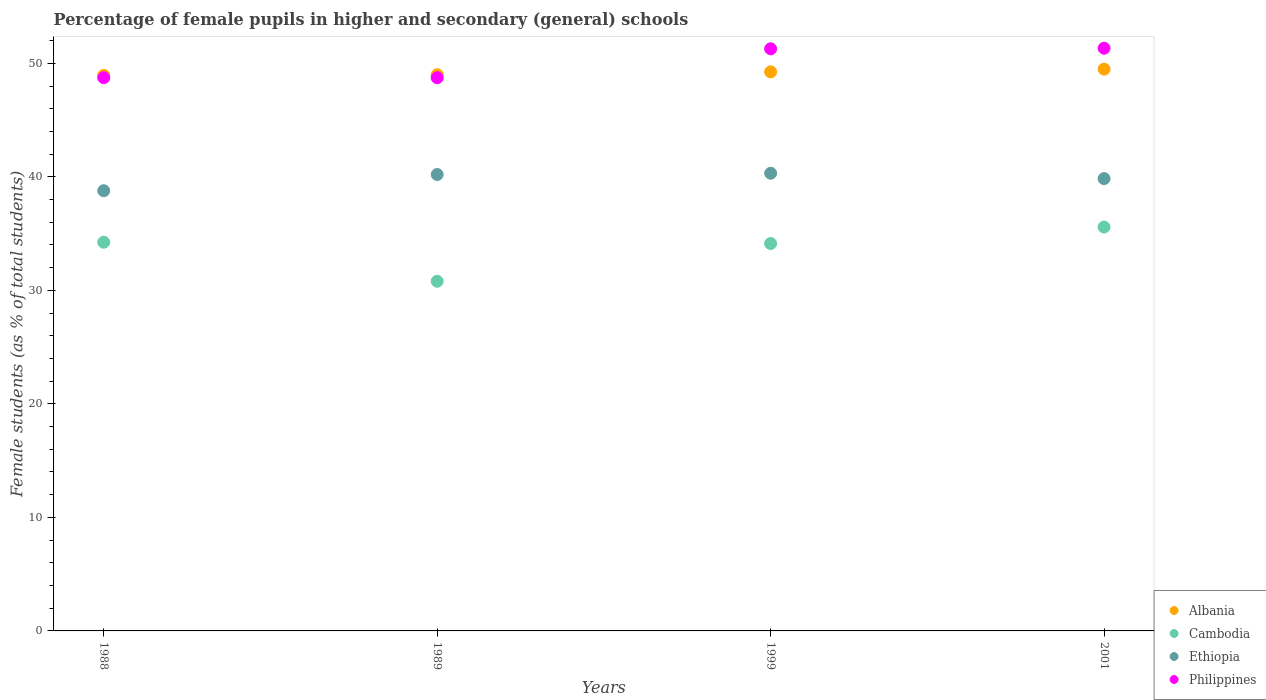What is the percentage of female pupils in higher and secondary schools in Albania in 1989?
Make the answer very short. 48.99. Across all years, what is the maximum percentage of female pupils in higher and secondary schools in Cambodia?
Make the answer very short. 35.57. Across all years, what is the minimum percentage of female pupils in higher and secondary schools in Ethiopia?
Provide a succinct answer. 38.78. What is the total percentage of female pupils in higher and secondary schools in Ethiopia in the graph?
Provide a short and direct response. 159.14. What is the difference between the percentage of female pupils in higher and secondary schools in Cambodia in 1989 and that in 2001?
Your response must be concise. -4.77. What is the difference between the percentage of female pupils in higher and secondary schools in Ethiopia in 1988 and the percentage of female pupils in higher and secondary schools in Cambodia in 1999?
Your response must be concise. 4.65. What is the average percentage of female pupils in higher and secondary schools in Albania per year?
Ensure brevity in your answer.  49.16. In the year 1988, what is the difference between the percentage of female pupils in higher and secondary schools in Ethiopia and percentage of female pupils in higher and secondary schools in Albania?
Give a very brief answer. -10.16. What is the ratio of the percentage of female pupils in higher and secondary schools in Philippines in 1988 to that in 2001?
Your answer should be compact. 0.95. Is the percentage of female pupils in higher and secondary schools in Ethiopia in 1999 less than that in 2001?
Offer a very short reply. No. Is the difference between the percentage of female pupils in higher and secondary schools in Ethiopia in 1988 and 2001 greater than the difference between the percentage of female pupils in higher and secondary schools in Albania in 1988 and 2001?
Provide a short and direct response. No. What is the difference between the highest and the second highest percentage of female pupils in higher and secondary schools in Cambodia?
Provide a short and direct response. 1.34. What is the difference between the highest and the lowest percentage of female pupils in higher and secondary schools in Ethiopia?
Offer a very short reply. 1.54. Is it the case that in every year, the sum of the percentage of female pupils in higher and secondary schools in Cambodia and percentage of female pupils in higher and secondary schools in Philippines  is greater than the sum of percentage of female pupils in higher and secondary schools in Albania and percentage of female pupils in higher and secondary schools in Ethiopia?
Provide a succinct answer. No. Is it the case that in every year, the sum of the percentage of female pupils in higher and secondary schools in Cambodia and percentage of female pupils in higher and secondary schools in Ethiopia  is greater than the percentage of female pupils in higher and secondary schools in Albania?
Offer a terse response. Yes. Is the percentage of female pupils in higher and secondary schools in Philippines strictly greater than the percentage of female pupils in higher and secondary schools in Ethiopia over the years?
Your response must be concise. Yes. How many dotlines are there?
Your response must be concise. 4. What is the difference between two consecutive major ticks on the Y-axis?
Offer a very short reply. 10. Does the graph contain any zero values?
Ensure brevity in your answer.  No. What is the title of the graph?
Provide a succinct answer. Percentage of female pupils in higher and secondary (general) schools. What is the label or title of the Y-axis?
Offer a terse response. Female students (as % of total students). What is the Female students (as % of total students) of Albania in 1988?
Ensure brevity in your answer.  48.94. What is the Female students (as % of total students) in Cambodia in 1988?
Provide a short and direct response. 34.24. What is the Female students (as % of total students) of Ethiopia in 1988?
Give a very brief answer. 38.78. What is the Female students (as % of total students) of Philippines in 1988?
Provide a succinct answer. 48.73. What is the Female students (as % of total students) of Albania in 1989?
Offer a terse response. 48.99. What is the Female students (as % of total students) in Cambodia in 1989?
Your answer should be compact. 30.8. What is the Female students (as % of total students) of Ethiopia in 1989?
Give a very brief answer. 40.2. What is the Female students (as % of total students) of Philippines in 1989?
Give a very brief answer. 48.73. What is the Female students (as % of total students) of Albania in 1999?
Your answer should be very brief. 49.25. What is the Female students (as % of total students) in Cambodia in 1999?
Offer a very short reply. 34.13. What is the Female students (as % of total students) in Ethiopia in 1999?
Make the answer very short. 40.31. What is the Female students (as % of total students) in Philippines in 1999?
Offer a very short reply. 51.28. What is the Female students (as % of total students) in Albania in 2001?
Offer a terse response. 49.48. What is the Female students (as % of total students) in Cambodia in 2001?
Give a very brief answer. 35.57. What is the Female students (as % of total students) of Ethiopia in 2001?
Offer a very short reply. 39.84. What is the Female students (as % of total students) in Philippines in 2001?
Provide a succinct answer. 51.33. Across all years, what is the maximum Female students (as % of total students) of Albania?
Offer a terse response. 49.48. Across all years, what is the maximum Female students (as % of total students) in Cambodia?
Make the answer very short. 35.57. Across all years, what is the maximum Female students (as % of total students) in Ethiopia?
Your answer should be compact. 40.31. Across all years, what is the maximum Female students (as % of total students) in Philippines?
Ensure brevity in your answer.  51.33. Across all years, what is the minimum Female students (as % of total students) in Albania?
Make the answer very short. 48.94. Across all years, what is the minimum Female students (as % of total students) of Cambodia?
Offer a very short reply. 30.8. Across all years, what is the minimum Female students (as % of total students) of Ethiopia?
Offer a very short reply. 38.78. Across all years, what is the minimum Female students (as % of total students) of Philippines?
Give a very brief answer. 48.73. What is the total Female students (as % of total students) in Albania in the graph?
Your response must be concise. 196.66. What is the total Female students (as % of total students) in Cambodia in the graph?
Ensure brevity in your answer.  134.75. What is the total Female students (as % of total students) in Ethiopia in the graph?
Provide a short and direct response. 159.14. What is the total Female students (as % of total students) of Philippines in the graph?
Provide a short and direct response. 200.07. What is the difference between the Female students (as % of total students) in Albania in 1988 and that in 1989?
Your answer should be compact. -0.06. What is the difference between the Female students (as % of total students) in Cambodia in 1988 and that in 1989?
Provide a short and direct response. 3.44. What is the difference between the Female students (as % of total students) in Ethiopia in 1988 and that in 1989?
Give a very brief answer. -1.43. What is the difference between the Female students (as % of total students) of Philippines in 1988 and that in 1989?
Give a very brief answer. 0. What is the difference between the Female students (as % of total students) in Albania in 1988 and that in 1999?
Provide a succinct answer. -0.31. What is the difference between the Female students (as % of total students) in Cambodia in 1988 and that in 1999?
Give a very brief answer. 0.11. What is the difference between the Female students (as % of total students) of Ethiopia in 1988 and that in 1999?
Your response must be concise. -1.54. What is the difference between the Female students (as % of total students) in Philippines in 1988 and that in 1999?
Provide a short and direct response. -2.55. What is the difference between the Female students (as % of total students) in Albania in 1988 and that in 2001?
Your response must be concise. -0.55. What is the difference between the Female students (as % of total students) in Cambodia in 1988 and that in 2001?
Your answer should be compact. -1.34. What is the difference between the Female students (as % of total students) in Ethiopia in 1988 and that in 2001?
Your answer should be very brief. -1.07. What is the difference between the Female students (as % of total students) in Philippines in 1988 and that in 2001?
Your answer should be compact. -2.6. What is the difference between the Female students (as % of total students) of Albania in 1989 and that in 1999?
Your answer should be very brief. -0.25. What is the difference between the Female students (as % of total students) in Cambodia in 1989 and that in 1999?
Your response must be concise. -3.32. What is the difference between the Female students (as % of total students) in Ethiopia in 1989 and that in 1999?
Provide a short and direct response. -0.11. What is the difference between the Female students (as % of total students) in Philippines in 1989 and that in 1999?
Make the answer very short. -2.55. What is the difference between the Female students (as % of total students) of Albania in 1989 and that in 2001?
Your answer should be very brief. -0.49. What is the difference between the Female students (as % of total students) of Cambodia in 1989 and that in 2001?
Make the answer very short. -4.77. What is the difference between the Female students (as % of total students) of Ethiopia in 1989 and that in 2001?
Keep it short and to the point. 0.36. What is the difference between the Female students (as % of total students) of Philippines in 1989 and that in 2001?
Offer a terse response. -2.6. What is the difference between the Female students (as % of total students) of Albania in 1999 and that in 2001?
Provide a succinct answer. -0.24. What is the difference between the Female students (as % of total students) in Cambodia in 1999 and that in 2001?
Provide a succinct answer. -1.45. What is the difference between the Female students (as % of total students) of Ethiopia in 1999 and that in 2001?
Your answer should be compact. 0.47. What is the difference between the Female students (as % of total students) of Philippines in 1999 and that in 2001?
Keep it short and to the point. -0.05. What is the difference between the Female students (as % of total students) in Albania in 1988 and the Female students (as % of total students) in Cambodia in 1989?
Keep it short and to the point. 18.13. What is the difference between the Female students (as % of total students) of Albania in 1988 and the Female students (as % of total students) of Ethiopia in 1989?
Offer a very short reply. 8.73. What is the difference between the Female students (as % of total students) in Albania in 1988 and the Female students (as % of total students) in Philippines in 1989?
Your response must be concise. 0.21. What is the difference between the Female students (as % of total students) in Cambodia in 1988 and the Female students (as % of total students) in Ethiopia in 1989?
Offer a very short reply. -5.96. What is the difference between the Female students (as % of total students) in Cambodia in 1988 and the Female students (as % of total students) in Philippines in 1989?
Your answer should be very brief. -14.49. What is the difference between the Female students (as % of total students) of Ethiopia in 1988 and the Female students (as % of total students) of Philippines in 1989?
Offer a terse response. -9.95. What is the difference between the Female students (as % of total students) in Albania in 1988 and the Female students (as % of total students) in Cambodia in 1999?
Provide a succinct answer. 14.81. What is the difference between the Female students (as % of total students) of Albania in 1988 and the Female students (as % of total students) of Ethiopia in 1999?
Make the answer very short. 8.62. What is the difference between the Female students (as % of total students) in Albania in 1988 and the Female students (as % of total students) in Philippines in 1999?
Your response must be concise. -2.34. What is the difference between the Female students (as % of total students) in Cambodia in 1988 and the Female students (as % of total students) in Ethiopia in 1999?
Provide a succinct answer. -6.08. What is the difference between the Female students (as % of total students) of Cambodia in 1988 and the Female students (as % of total students) of Philippines in 1999?
Your answer should be very brief. -17.04. What is the difference between the Female students (as % of total students) in Ethiopia in 1988 and the Female students (as % of total students) in Philippines in 1999?
Your answer should be very brief. -12.5. What is the difference between the Female students (as % of total students) in Albania in 1988 and the Female students (as % of total students) in Cambodia in 2001?
Make the answer very short. 13.36. What is the difference between the Female students (as % of total students) in Albania in 1988 and the Female students (as % of total students) in Ethiopia in 2001?
Your answer should be very brief. 9.09. What is the difference between the Female students (as % of total students) in Albania in 1988 and the Female students (as % of total students) in Philippines in 2001?
Give a very brief answer. -2.39. What is the difference between the Female students (as % of total students) in Cambodia in 1988 and the Female students (as % of total students) in Ethiopia in 2001?
Your response must be concise. -5.6. What is the difference between the Female students (as % of total students) of Cambodia in 1988 and the Female students (as % of total students) of Philippines in 2001?
Your answer should be compact. -17.09. What is the difference between the Female students (as % of total students) in Ethiopia in 1988 and the Female students (as % of total students) in Philippines in 2001?
Provide a succinct answer. -12.55. What is the difference between the Female students (as % of total students) of Albania in 1989 and the Female students (as % of total students) of Cambodia in 1999?
Make the answer very short. 14.87. What is the difference between the Female students (as % of total students) in Albania in 1989 and the Female students (as % of total students) in Ethiopia in 1999?
Ensure brevity in your answer.  8.68. What is the difference between the Female students (as % of total students) of Albania in 1989 and the Female students (as % of total students) of Philippines in 1999?
Your answer should be very brief. -2.28. What is the difference between the Female students (as % of total students) of Cambodia in 1989 and the Female students (as % of total students) of Ethiopia in 1999?
Give a very brief answer. -9.51. What is the difference between the Female students (as % of total students) of Cambodia in 1989 and the Female students (as % of total students) of Philippines in 1999?
Provide a short and direct response. -20.47. What is the difference between the Female students (as % of total students) in Ethiopia in 1989 and the Female students (as % of total students) in Philippines in 1999?
Ensure brevity in your answer.  -11.07. What is the difference between the Female students (as % of total students) of Albania in 1989 and the Female students (as % of total students) of Cambodia in 2001?
Provide a short and direct response. 13.42. What is the difference between the Female students (as % of total students) of Albania in 1989 and the Female students (as % of total students) of Ethiopia in 2001?
Ensure brevity in your answer.  9.15. What is the difference between the Female students (as % of total students) of Albania in 1989 and the Female students (as % of total students) of Philippines in 2001?
Make the answer very short. -2.33. What is the difference between the Female students (as % of total students) in Cambodia in 1989 and the Female students (as % of total students) in Ethiopia in 2001?
Make the answer very short. -9.04. What is the difference between the Female students (as % of total students) in Cambodia in 1989 and the Female students (as % of total students) in Philippines in 2001?
Your answer should be very brief. -20.52. What is the difference between the Female students (as % of total students) in Ethiopia in 1989 and the Female students (as % of total students) in Philippines in 2001?
Offer a terse response. -11.12. What is the difference between the Female students (as % of total students) of Albania in 1999 and the Female students (as % of total students) of Cambodia in 2001?
Keep it short and to the point. 13.67. What is the difference between the Female students (as % of total students) in Albania in 1999 and the Female students (as % of total students) in Ethiopia in 2001?
Offer a terse response. 9.4. What is the difference between the Female students (as % of total students) of Albania in 1999 and the Female students (as % of total students) of Philippines in 2001?
Provide a short and direct response. -2.08. What is the difference between the Female students (as % of total students) of Cambodia in 1999 and the Female students (as % of total students) of Ethiopia in 2001?
Provide a succinct answer. -5.72. What is the difference between the Female students (as % of total students) of Cambodia in 1999 and the Female students (as % of total students) of Philippines in 2001?
Provide a succinct answer. -17.2. What is the difference between the Female students (as % of total students) in Ethiopia in 1999 and the Female students (as % of total students) in Philippines in 2001?
Ensure brevity in your answer.  -11.01. What is the average Female students (as % of total students) in Albania per year?
Offer a very short reply. 49.16. What is the average Female students (as % of total students) in Cambodia per year?
Make the answer very short. 33.69. What is the average Female students (as % of total students) in Ethiopia per year?
Your response must be concise. 39.78. What is the average Female students (as % of total students) in Philippines per year?
Give a very brief answer. 50.02. In the year 1988, what is the difference between the Female students (as % of total students) of Albania and Female students (as % of total students) of Cambodia?
Your response must be concise. 14.7. In the year 1988, what is the difference between the Female students (as % of total students) of Albania and Female students (as % of total students) of Ethiopia?
Provide a short and direct response. 10.16. In the year 1988, what is the difference between the Female students (as % of total students) in Albania and Female students (as % of total students) in Philippines?
Provide a succinct answer. 0.21. In the year 1988, what is the difference between the Female students (as % of total students) in Cambodia and Female students (as % of total students) in Ethiopia?
Make the answer very short. -4.54. In the year 1988, what is the difference between the Female students (as % of total students) in Cambodia and Female students (as % of total students) in Philippines?
Your answer should be very brief. -14.49. In the year 1988, what is the difference between the Female students (as % of total students) in Ethiopia and Female students (as % of total students) in Philippines?
Your answer should be very brief. -9.95. In the year 1989, what is the difference between the Female students (as % of total students) of Albania and Female students (as % of total students) of Cambodia?
Offer a terse response. 18.19. In the year 1989, what is the difference between the Female students (as % of total students) in Albania and Female students (as % of total students) in Ethiopia?
Ensure brevity in your answer.  8.79. In the year 1989, what is the difference between the Female students (as % of total students) in Albania and Female students (as % of total students) in Philippines?
Keep it short and to the point. 0.26. In the year 1989, what is the difference between the Female students (as % of total students) in Cambodia and Female students (as % of total students) in Ethiopia?
Make the answer very short. -9.4. In the year 1989, what is the difference between the Female students (as % of total students) of Cambodia and Female students (as % of total students) of Philippines?
Ensure brevity in your answer.  -17.93. In the year 1989, what is the difference between the Female students (as % of total students) of Ethiopia and Female students (as % of total students) of Philippines?
Give a very brief answer. -8.53. In the year 1999, what is the difference between the Female students (as % of total students) of Albania and Female students (as % of total students) of Cambodia?
Make the answer very short. 15.12. In the year 1999, what is the difference between the Female students (as % of total students) in Albania and Female students (as % of total students) in Ethiopia?
Your answer should be compact. 8.93. In the year 1999, what is the difference between the Female students (as % of total students) of Albania and Female students (as % of total students) of Philippines?
Offer a terse response. -2.03. In the year 1999, what is the difference between the Female students (as % of total students) in Cambodia and Female students (as % of total students) in Ethiopia?
Ensure brevity in your answer.  -6.19. In the year 1999, what is the difference between the Female students (as % of total students) of Cambodia and Female students (as % of total students) of Philippines?
Provide a short and direct response. -17.15. In the year 1999, what is the difference between the Female students (as % of total students) in Ethiopia and Female students (as % of total students) in Philippines?
Your answer should be compact. -10.96. In the year 2001, what is the difference between the Female students (as % of total students) in Albania and Female students (as % of total students) in Cambodia?
Provide a succinct answer. 13.91. In the year 2001, what is the difference between the Female students (as % of total students) of Albania and Female students (as % of total students) of Ethiopia?
Offer a terse response. 9.64. In the year 2001, what is the difference between the Female students (as % of total students) in Albania and Female students (as % of total students) in Philippines?
Offer a terse response. -1.84. In the year 2001, what is the difference between the Female students (as % of total students) in Cambodia and Female students (as % of total students) in Ethiopia?
Offer a very short reply. -4.27. In the year 2001, what is the difference between the Female students (as % of total students) of Cambodia and Female students (as % of total students) of Philippines?
Make the answer very short. -15.75. In the year 2001, what is the difference between the Female students (as % of total students) in Ethiopia and Female students (as % of total students) in Philippines?
Provide a short and direct response. -11.49. What is the ratio of the Female students (as % of total students) of Cambodia in 1988 to that in 1989?
Your answer should be compact. 1.11. What is the ratio of the Female students (as % of total students) in Ethiopia in 1988 to that in 1989?
Your answer should be compact. 0.96. What is the ratio of the Female students (as % of total students) in Cambodia in 1988 to that in 1999?
Give a very brief answer. 1. What is the ratio of the Female students (as % of total students) in Ethiopia in 1988 to that in 1999?
Your response must be concise. 0.96. What is the ratio of the Female students (as % of total students) in Philippines in 1988 to that in 1999?
Your response must be concise. 0.95. What is the ratio of the Female students (as % of total students) of Albania in 1988 to that in 2001?
Provide a succinct answer. 0.99. What is the ratio of the Female students (as % of total students) of Cambodia in 1988 to that in 2001?
Your answer should be very brief. 0.96. What is the ratio of the Female students (as % of total students) in Ethiopia in 1988 to that in 2001?
Make the answer very short. 0.97. What is the ratio of the Female students (as % of total students) in Philippines in 1988 to that in 2001?
Keep it short and to the point. 0.95. What is the ratio of the Female students (as % of total students) of Cambodia in 1989 to that in 1999?
Offer a very short reply. 0.9. What is the ratio of the Female students (as % of total students) of Ethiopia in 1989 to that in 1999?
Offer a terse response. 1. What is the ratio of the Female students (as % of total students) of Philippines in 1989 to that in 1999?
Keep it short and to the point. 0.95. What is the ratio of the Female students (as % of total students) of Albania in 1989 to that in 2001?
Provide a short and direct response. 0.99. What is the ratio of the Female students (as % of total students) of Cambodia in 1989 to that in 2001?
Ensure brevity in your answer.  0.87. What is the ratio of the Female students (as % of total students) in Ethiopia in 1989 to that in 2001?
Give a very brief answer. 1.01. What is the ratio of the Female students (as % of total students) of Philippines in 1989 to that in 2001?
Offer a very short reply. 0.95. What is the ratio of the Female students (as % of total students) in Albania in 1999 to that in 2001?
Make the answer very short. 1. What is the ratio of the Female students (as % of total students) in Cambodia in 1999 to that in 2001?
Keep it short and to the point. 0.96. What is the ratio of the Female students (as % of total students) in Ethiopia in 1999 to that in 2001?
Ensure brevity in your answer.  1.01. What is the ratio of the Female students (as % of total students) in Philippines in 1999 to that in 2001?
Your response must be concise. 1. What is the difference between the highest and the second highest Female students (as % of total students) of Albania?
Your answer should be very brief. 0.24. What is the difference between the highest and the second highest Female students (as % of total students) of Cambodia?
Provide a succinct answer. 1.34. What is the difference between the highest and the second highest Female students (as % of total students) in Ethiopia?
Offer a very short reply. 0.11. What is the difference between the highest and the second highest Female students (as % of total students) of Philippines?
Your response must be concise. 0.05. What is the difference between the highest and the lowest Female students (as % of total students) in Albania?
Your answer should be compact. 0.55. What is the difference between the highest and the lowest Female students (as % of total students) of Cambodia?
Make the answer very short. 4.77. What is the difference between the highest and the lowest Female students (as % of total students) in Ethiopia?
Your answer should be compact. 1.54. What is the difference between the highest and the lowest Female students (as % of total students) of Philippines?
Provide a succinct answer. 2.6. 